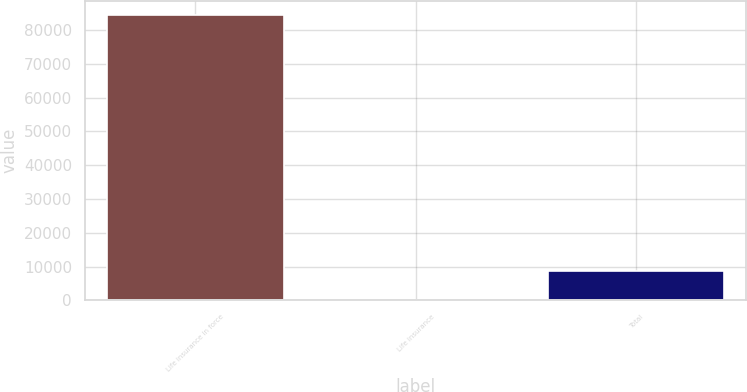<chart> <loc_0><loc_0><loc_500><loc_500><bar_chart><fcel>Life insurance in force<fcel>Life insurance<fcel>Total<nl><fcel>84403.8<fcel>146.2<fcel>8571.96<nl></chart> 